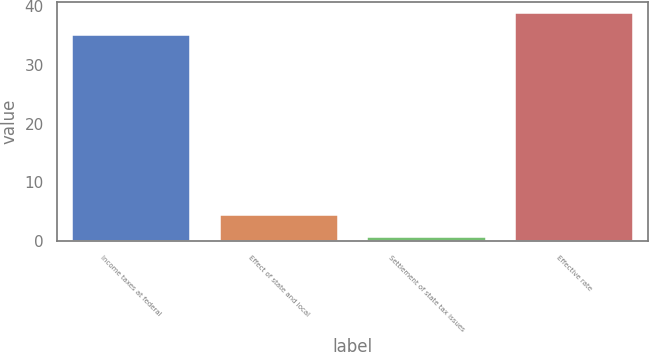<chart> <loc_0><loc_0><loc_500><loc_500><bar_chart><fcel>Income taxes at federal<fcel>Effect of state and local<fcel>Settlement of state tax issues<fcel>Effective rate<nl><fcel>35<fcel>4.38<fcel>0.68<fcel>38.7<nl></chart> 